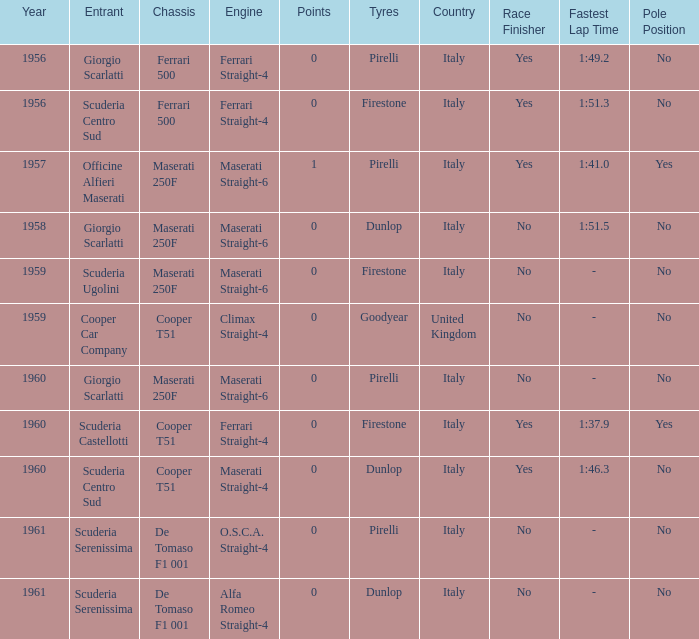I'm looking to parse the entire table for insights. Could you assist me with that? {'header': ['Year', 'Entrant', 'Chassis', 'Engine', 'Points', 'Tyres', 'Country', 'Race Finisher', 'Fastest Lap Time', 'Pole Position'], 'rows': [['1956', 'Giorgio Scarlatti', 'Ferrari 500', 'Ferrari Straight-4', '0', 'Pirelli', 'Italy', 'Yes', '1:49.2', 'No'], ['1956', 'Scuderia Centro Sud', 'Ferrari 500', 'Ferrari Straight-4', '0', 'Firestone', 'Italy', 'Yes', '1:51.3', 'No'], ['1957', 'Officine Alfieri Maserati', 'Maserati 250F', 'Maserati Straight-6', '1', 'Pirelli', 'Italy', 'Yes', '1:41.0', 'Yes'], ['1958', 'Giorgio Scarlatti', 'Maserati 250F', 'Maserati Straight-6', '0', 'Dunlop', 'Italy', 'No', '1:51.5', 'No'], ['1959', 'Scuderia Ugolini', 'Maserati 250F', 'Maserati Straight-6', '0', 'Firestone', 'Italy', 'No', '-', 'No'], ['1959', 'Cooper Car Company', 'Cooper T51', 'Climax Straight-4', '0', 'Goodyear', 'United Kingdom', 'No', '-', 'No'], ['1960', 'Giorgio Scarlatti', 'Maserati 250F', 'Maserati Straight-6', '0', 'Pirelli', 'Italy', 'No', '-', 'No'], ['1960', 'Scuderia Castellotti', 'Cooper T51', 'Ferrari Straight-4', '0', 'Firestone', 'Italy', 'Yes', '1:37.9', 'Yes'], ['1960', 'Scuderia Centro Sud', 'Cooper T51', 'Maserati Straight-4', '0', 'Dunlop', 'Italy', 'Yes', '1:46.3', 'No'], ['1961', 'Scuderia Serenissima', 'De Tomaso F1 001', 'O.S.C.A. Straight-4', '0', 'Pirelli', 'Italy', 'No', '-', 'No'], ['1961', 'Scuderia Serenissima', 'De Tomaso F1 001', 'Alfa Romeo Straight-4', '0', 'Dunlop', 'Italy', 'No', '-', 'No']]} How many points for the cooper car company after 1959? None. 